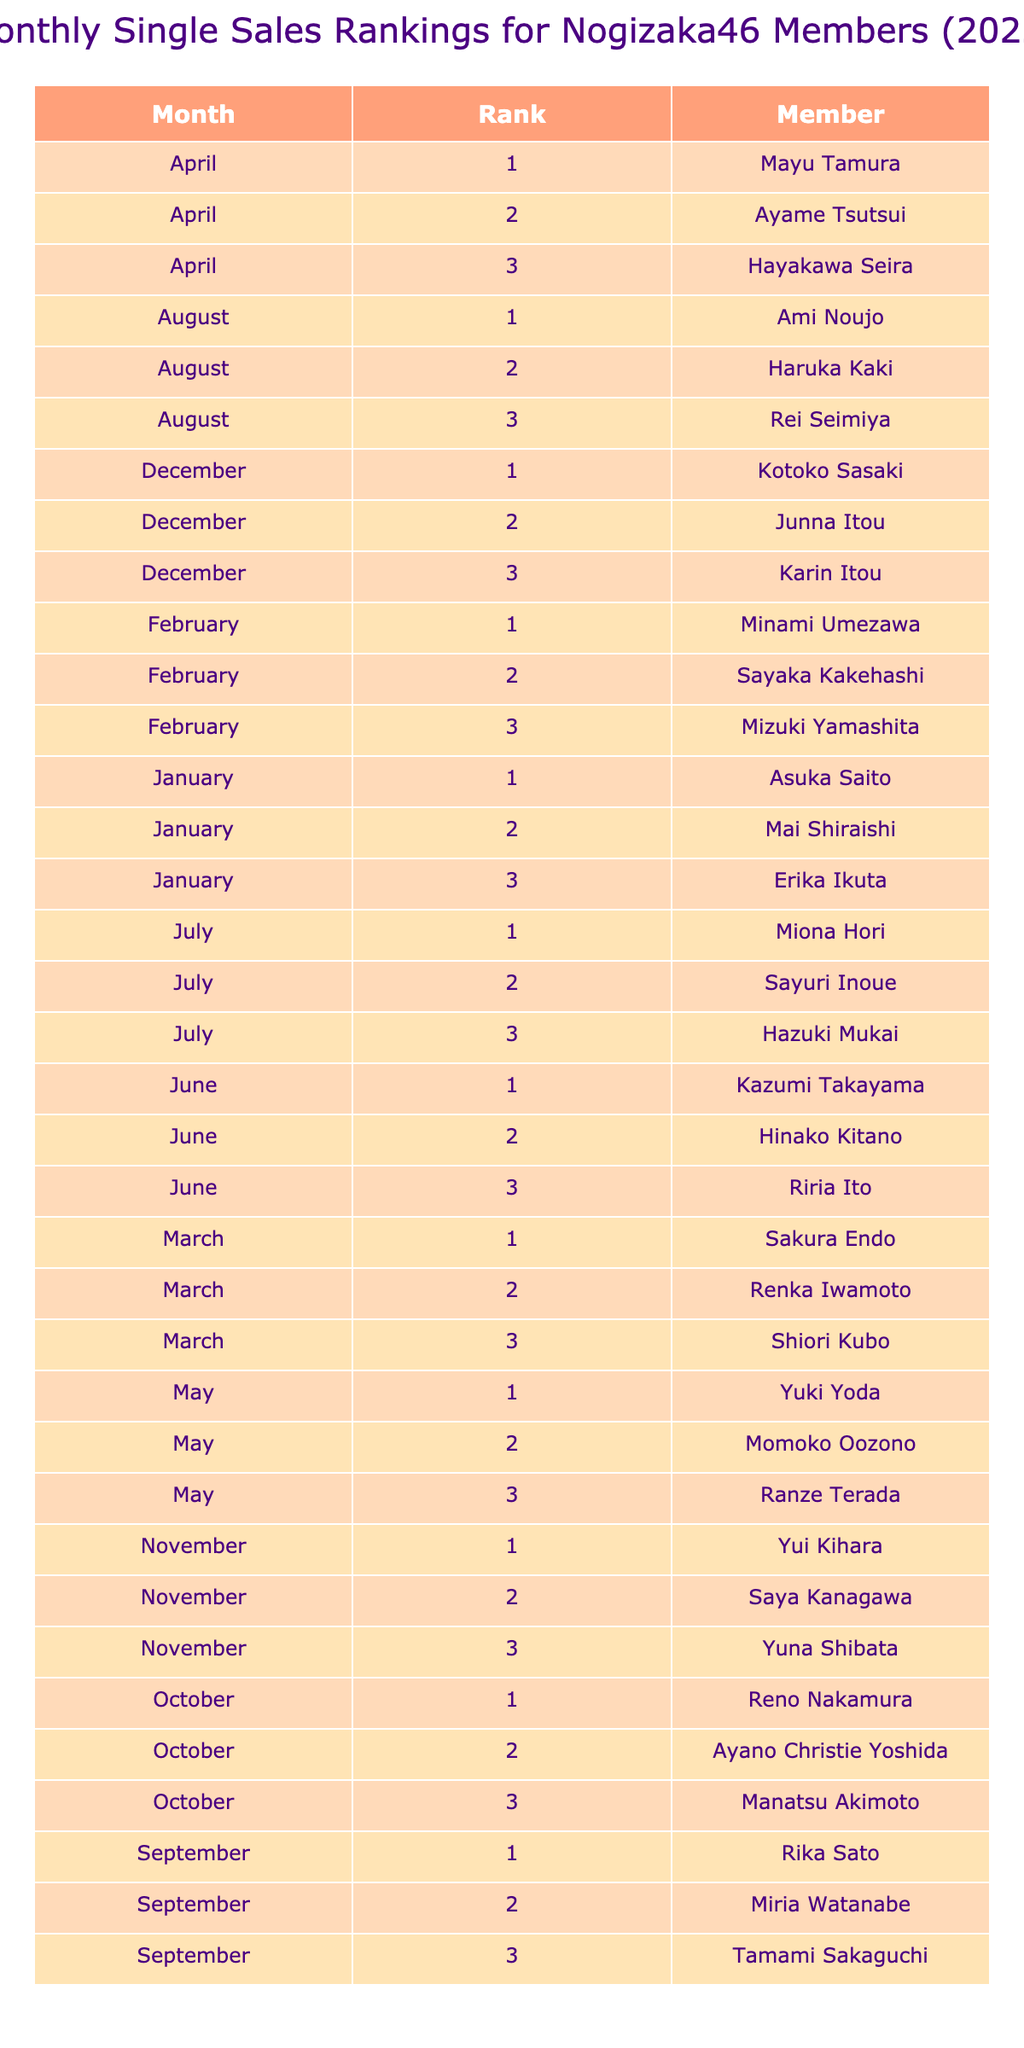What is the rank of Asuka Saito in January? The table indicates that Asuka Saito holds the 1st rank in January.
Answer: 1 Who ranked 3rd in November? According to the table, Yuna Shibata is ranked 3rd in November.
Answer: Yuna Shibata Which member had the best sales rank in March? The table shows that Sakura Endo had the best rank, which is 1st in March.
Answer: Sakura Endo How many different members ranked first from January to December? From the table, I can see that different members have ranked 1st each month, totaling 12 unique members for the year.
Answer: 12 Did any member rank 2nd in December? The table reveals that Junna Itou ranked 2nd in December, verifying that yes, there was a member in that position.
Answer: Yes What is the average rank of the members in April? In April, Mayu Tamura is 1st, Ayame Tsutsui is 2nd, and Hayakawa Seira is 3rd. Summing the ranks (1 + 2 + 3) gives 6, and dividing by 3 (the number of members) yields an average rank of 2.
Answer: 2 Which month had the highest number of unique rankings? By checking the table, each month has one unique ranking per member, thus all months (January to December) have 3 unique rankings each.
Answer: All months Are there more members with 1st rank in the first half of the year compared to the second half? Upon reviewing the table, there are 6 members with 1st rank in the first half (January to June) and 6 members in the second half (July to December), so the count is equal.
Answer: No Which member ranked 3rd in June? The table indicates that Riria Ito ranked 3rd in June.
Answer: Riria Ito Who ranked 1st for the most months? Analyzing the table, I see that each member ranked 1st in only one month. Therefore, there is no member that ranked 1st for more than one month in the data provided.
Answer: None 